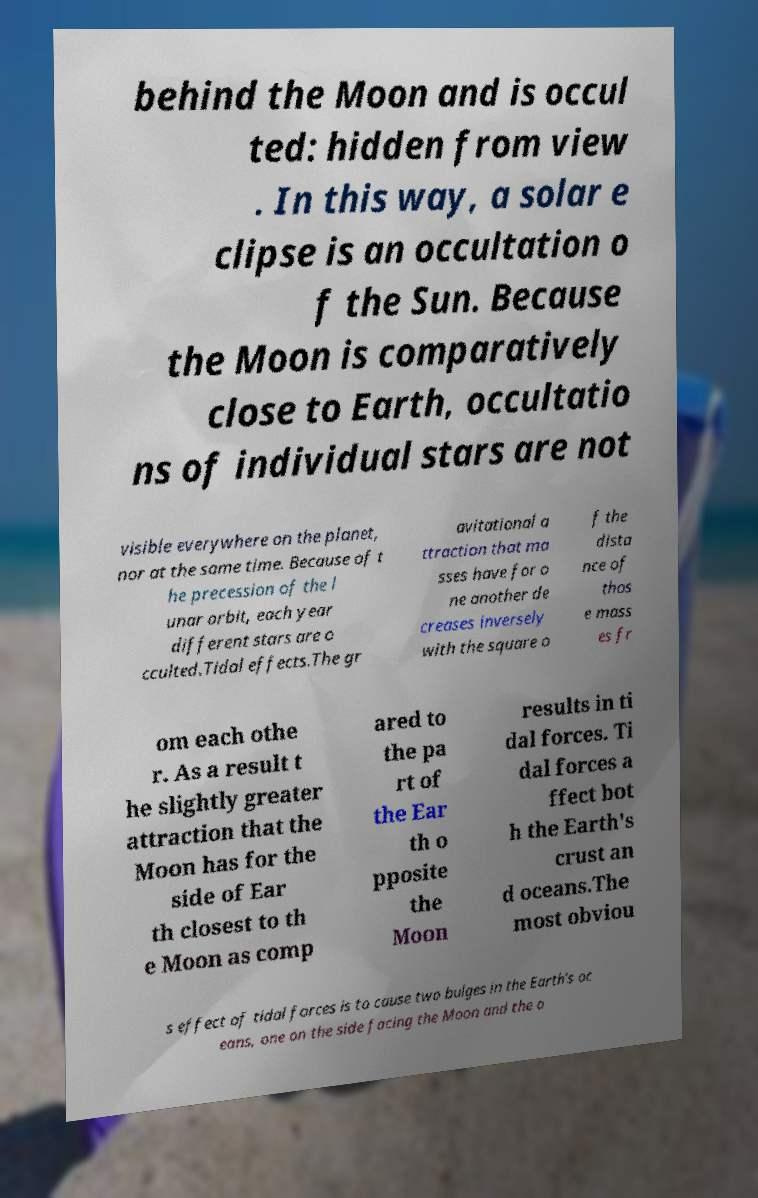Can you read and provide the text displayed in the image?This photo seems to have some interesting text. Can you extract and type it out for me? behind the Moon and is occul ted: hidden from view . In this way, a solar e clipse is an occultation o f the Sun. Because the Moon is comparatively close to Earth, occultatio ns of individual stars are not visible everywhere on the planet, nor at the same time. Because of t he precession of the l unar orbit, each year different stars are o cculted.Tidal effects.The gr avitational a ttraction that ma sses have for o ne another de creases inversely with the square o f the dista nce of thos e mass es fr om each othe r. As a result t he slightly greater attraction that the Moon has for the side of Ear th closest to th e Moon as comp ared to the pa rt of the Ear th o pposite the Moon results in ti dal forces. Ti dal forces a ffect bot h the Earth's crust an d oceans.The most obviou s effect of tidal forces is to cause two bulges in the Earth's oc eans, one on the side facing the Moon and the o 